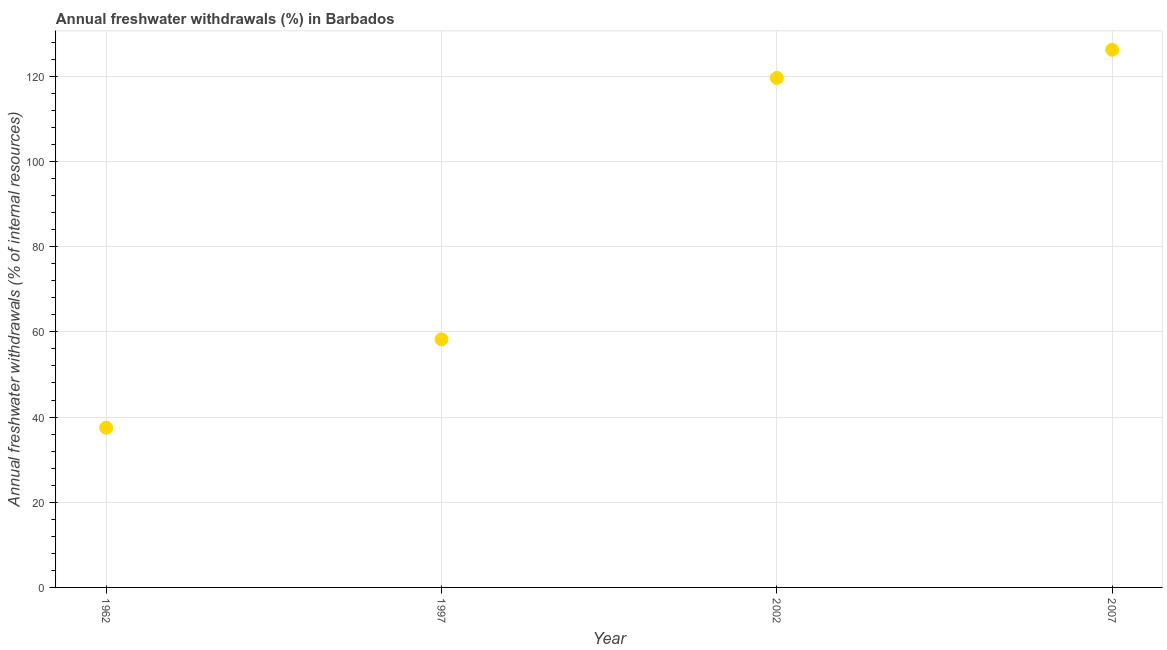What is the annual freshwater withdrawals in 1962?
Give a very brief answer. 37.5. Across all years, what is the maximum annual freshwater withdrawals?
Provide a succinct answer. 126.25. Across all years, what is the minimum annual freshwater withdrawals?
Provide a short and direct response. 37.5. In which year was the annual freshwater withdrawals maximum?
Provide a short and direct response. 2007. In which year was the annual freshwater withdrawals minimum?
Offer a terse response. 1962. What is the sum of the annual freshwater withdrawals?
Make the answer very short. 341.62. What is the difference between the annual freshwater withdrawals in 1962 and 2007?
Offer a very short reply. -88.75. What is the average annual freshwater withdrawals per year?
Offer a terse response. 85.41. What is the median annual freshwater withdrawals?
Offer a terse response. 88.94. In how many years, is the annual freshwater withdrawals greater than 60 %?
Your answer should be compact. 2. Do a majority of the years between 1997 and 2007 (inclusive) have annual freshwater withdrawals greater than 4 %?
Your answer should be compact. Yes. What is the ratio of the annual freshwater withdrawals in 2002 to that in 2007?
Your response must be concise. 0.95. Is the annual freshwater withdrawals in 2002 less than that in 2007?
Provide a succinct answer. Yes. Is the difference between the annual freshwater withdrawals in 1962 and 2002 greater than the difference between any two years?
Keep it short and to the point. No. What is the difference between the highest and the second highest annual freshwater withdrawals?
Your answer should be very brief. 6.62. Is the sum of the annual freshwater withdrawals in 1997 and 2007 greater than the maximum annual freshwater withdrawals across all years?
Provide a succinct answer. Yes. What is the difference between the highest and the lowest annual freshwater withdrawals?
Your response must be concise. 88.75. In how many years, is the annual freshwater withdrawals greater than the average annual freshwater withdrawals taken over all years?
Your answer should be very brief. 2. Does the annual freshwater withdrawals monotonically increase over the years?
Offer a terse response. Yes. Does the graph contain any zero values?
Ensure brevity in your answer.  No. What is the title of the graph?
Provide a succinct answer. Annual freshwater withdrawals (%) in Barbados. What is the label or title of the Y-axis?
Ensure brevity in your answer.  Annual freshwater withdrawals (% of internal resources). What is the Annual freshwater withdrawals (% of internal resources) in 1962?
Provide a short and direct response. 37.5. What is the Annual freshwater withdrawals (% of internal resources) in 1997?
Offer a very short reply. 58.25. What is the Annual freshwater withdrawals (% of internal resources) in 2002?
Offer a very short reply. 119.62. What is the Annual freshwater withdrawals (% of internal resources) in 2007?
Ensure brevity in your answer.  126.25. What is the difference between the Annual freshwater withdrawals (% of internal resources) in 1962 and 1997?
Your answer should be very brief. -20.75. What is the difference between the Annual freshwater withdrawals (% of internal resources) in 1962 and 2002?
Your answer should be compact. -82.12. What is the difference between the Annual freshwater withdrawals (% of internal resources) in 1962 and 2007?
Give a very brief answer. -88.75. What is the difference between the Annual freshwater withdrawals (% of internal resources) in 1997 and 2002?
Give a very brief answer. -61.38. What is the difference between the Annual freshwater withdrawals (% of internal resources) in 1997 and 2007?
Your answer should be compact. -68. What is the difference between the Annual freshwater withdrawals (% of internal resources) in 2002 and 2007?
Your answer should be very brief. -6.62. What is the ratio of the Annual freshwater withdrawals (% of internal resources) in 1962 to that in 1997?
Ensure brevity in your answer.  0.64. What is the ratio of the Annual freshwater withdrawals (% of internal resources) in 1962 to that in 2002?
Make the answer very short. 0.31. What is the ratio of the Annual freshwater withdrawals (% of internal resources) in 1962 to that in 2007?
Offer a terse response. 0.3. What is the ratio of the Annual freshwater withdrawals (% of internal resources) in 1997 to that in 2002?
Make the answer very short. 0.49. What is the ratio of the Annual freshwater withdrawals (% of internal resources) in 1997 to that in 2007?
Make the answer very short. 0.46. What is the ratio of the Annual freshwater withdrawals (% of internal resources) in 2002 to that in 2007?
Offer a terse response. 0.95. 